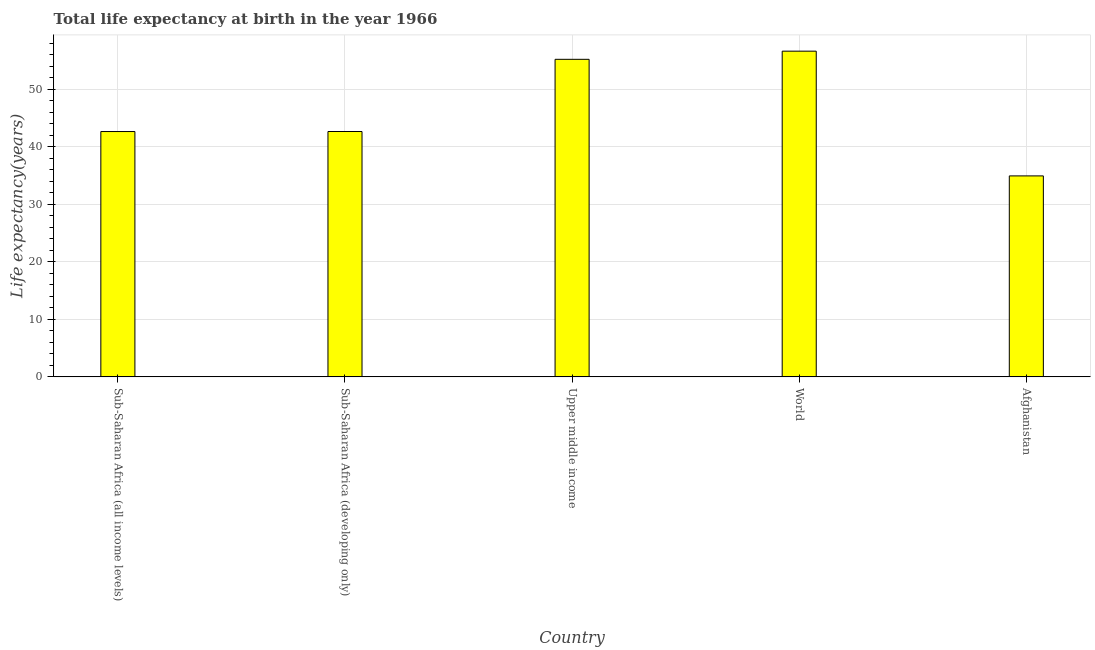Does the graph contain grids?
Give a very brief answer. Yes. What is the title of the graph?
Ensure brevity in your answer.  Total life expectancy at birth in the year 1966. What is the label or title of the Y-axis?
Your response must be concise. Life expectancy(years). What is the life expectancy at birth in Sub-Saharan Africa (developing only)?
Your response must be concise. 42.68. Across all countries, what is the maximum life expectancy at birth?
Your answer should be very brief. 56.66. Across all countries, what is the minimum life expectancy at birth?
Offer a terse response. 34.96. In which country was the life expectancy at birth minimum?
Your answer should be very brief. Afghanistan. What is the sum of the life expectancy at birth?
Your response must be concise. 232.2. What is the difference between the life expectancy at birth in Afghanistan and Upper middle income?
Your response must be concise. -20.28. What is the average life expectancy at birth per country?
Offer a terse response. 46.44. What is the median life expectancy at birth?
Make the answer very short. 42.68. In how many countries, is the life expectancy at birth greater than 22 years?
Your response must be concise. 5. What is the difference between the highest and the second highest life expectancy at birth?
Provide a short and direct response. 1.42. What is the difference between the highest and the lowest life expectancy at birth?
Your response must be concise. 21.7. In how many countries, is the life expectancy at birth greater than the average life expectancy at birth taken over all countries?
Ensure brevity in your answer.  2. How many bars are there?
Provide a short and direct response. 5. How many countries are there in the graph?
Make the answer very short. 5. What is the difference between two consecutive major ticks on the Y-axis?
Give a very brief answer. 10. What is the Life expectancy(years) in Sub-Saharan Africa (all income levels)?
Offer a terse response. 42.68. What is the Life expectancy(years) of Sub-Saharan Africa (developing only)?
Give a very brief answer. 42.68. What is the Life expectancy(years) of Upper middle income?
Offer a very short reply. 55.24. What is the Life expectancy(years) of World?
Offer a very short reply. 56.66. What is the Life expectancy(years) in Afghanistan?
Your response must be concise. 34.96. What is the difference between the Life expectancy(years) in Sub-Saharan Africa (all income levels) and Sub-Saharan Africa (developing only)?
Your response must be concise. -0. What is the difference between the Life expectancy(years) in Sub-Saharan Africa (all income levels) and Upper middle income?
Keep it short and to the point. -12.56. What is the difference between the Life expectancy(years) in Sub-Saharan Africa (all income levels) and World?
Offer a very short reply. -13.98. What is the difference between the Life expectancy(years) in Sub-Saharan Africa (all income levels) and Afghanistan?
Your response must be concise. 7.72. What is the difference between the Life expectancy(years) in Sub-Saharan Africa (developing only) and Upper middle income?
Keep it short and to the point. -12.56. What is the difference between the Life expectancy(years) in Sub-Saharan Africa (developing only) and World?
Give a very brief answer. -13.98. What is the difference between the Life expectancy(years) in Sub-Saharan Africa (developing only) and Afghanistan?
Make the answer very short. 7.72. What is the difference between the Life expectancy(years) in Upper middle income and World?
Your answer should be very brief. -1.42. What is the difference between the Life expectancy(years) in Upper middle income and Afghanistan?
Ensure brevity in your answer.  20.28. What is the difference between the Life expectancy(years) in World and Afghanistan?
Offer a terse response. 21.7. What is the ratio of the Life expectancy(years) in Sub-Saharan Africa (all income levels) to that in Upper middle income?
Offer a terse response. 0.77. What is the ratio of the Life expectancy(years) in Sub-Saharan Africa (all income levels) to that in World?
Offer a very short reply. 0.75. What is the ratio of the Life expectancy(years) in Sub-Saharan Africa (all income levels) to that in Afghanistan?
Give a very brief answer. 1.22. What is the ratio of the Life expectancy(years) in Sub-Saharan Africa (developing only) to that in Upper middle income?
Make the answer very short. 0.77. What is the ratio of the Life expectancy(years) in Sub-Saharan Africa (developing only) to that in World?
Your response must be concise. 0.75. What is the ratio of the Life expectancy(years) in Sub-Saharan Africa (developing only) to that in Afghanistan?
Give a very brief answer. 1.22. What is the ratio of the Life expectancy(years) in Upper middle income to that in Afghanistan?
Provide a succinct answer. 1.58. What is the ratio of the Life expectancy(years) in World to that in Afghanistan?
Keep it short and to the point. 1.62. 